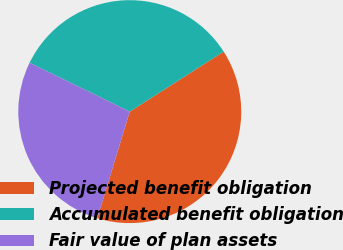<chart> <loc_0><loc_0><loc_500><loc_500><pie_chart><fcel>Projected benefit obligation<fcel>Accumulated benefit obligation<fcel>Fair value of plan assets<nl><fcel>38.76%<fcel>33.72%<fcel>27.52%<nl></chart> 